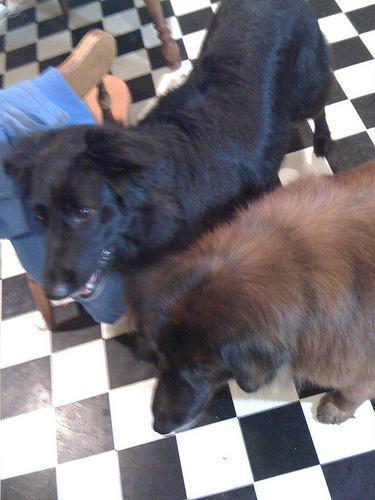How many animals?
Give a very brief answer. 2. 